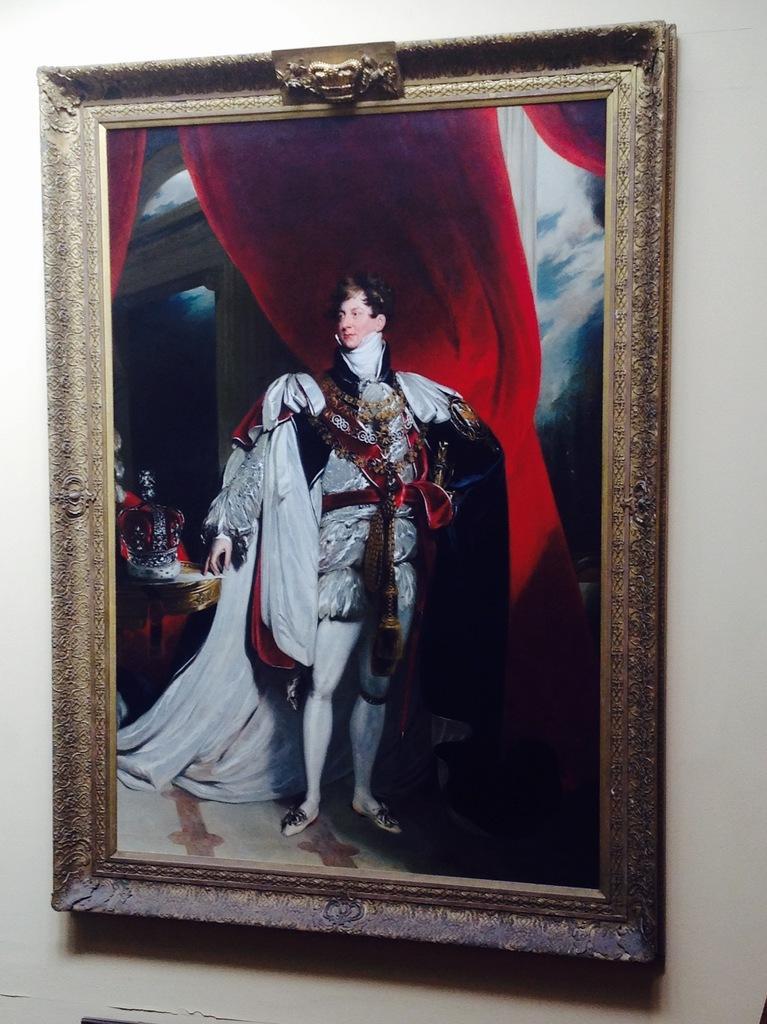How would you summarize this image in a sentence or two? Here I can see a photo frame is attached to the wall. On the photo frame, I can see a person wearing costume and standing. At the back of this person there are red color curtains. 